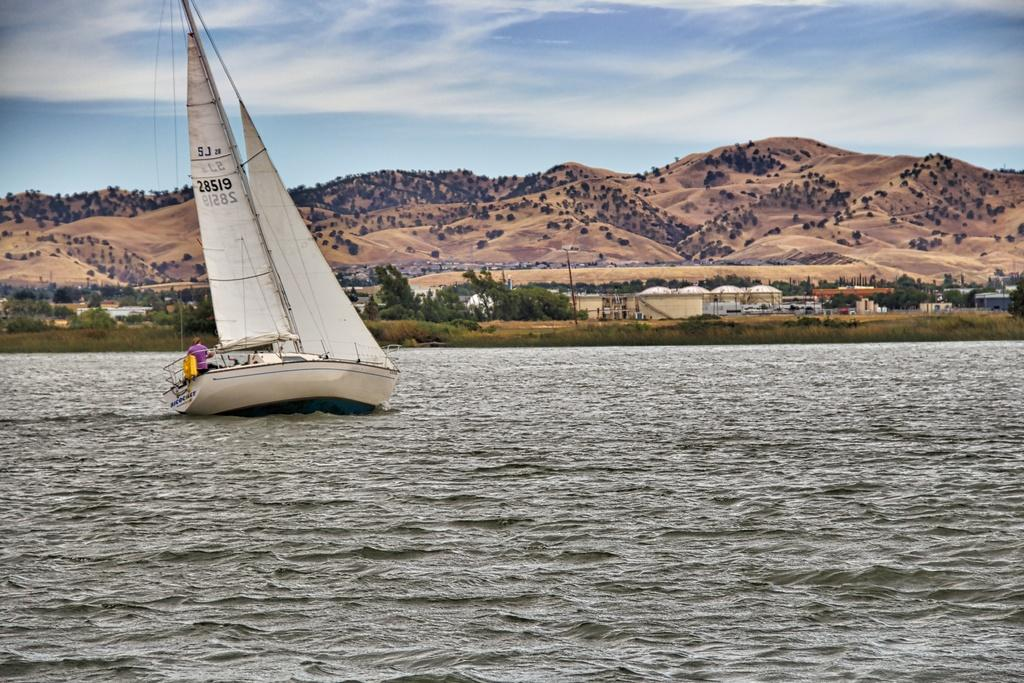What is the main subject of the image? The main subject of the image is a ship. Where is the ship located? The ship is on the sea. Can you describe the person in the ship? There is a person in the ship, but their appearance or actions are not specified in the facts. What can be seen in the background of the image? In the background of the image, there are trees, buildings, poles, and hills. What type of toothbrush is the person using on the ship? There is no toothbrush present in the image, and the person's actions are not specified. What is the route the ship is taking in the image? The facts provided do not indicate the ship's route or direction. 